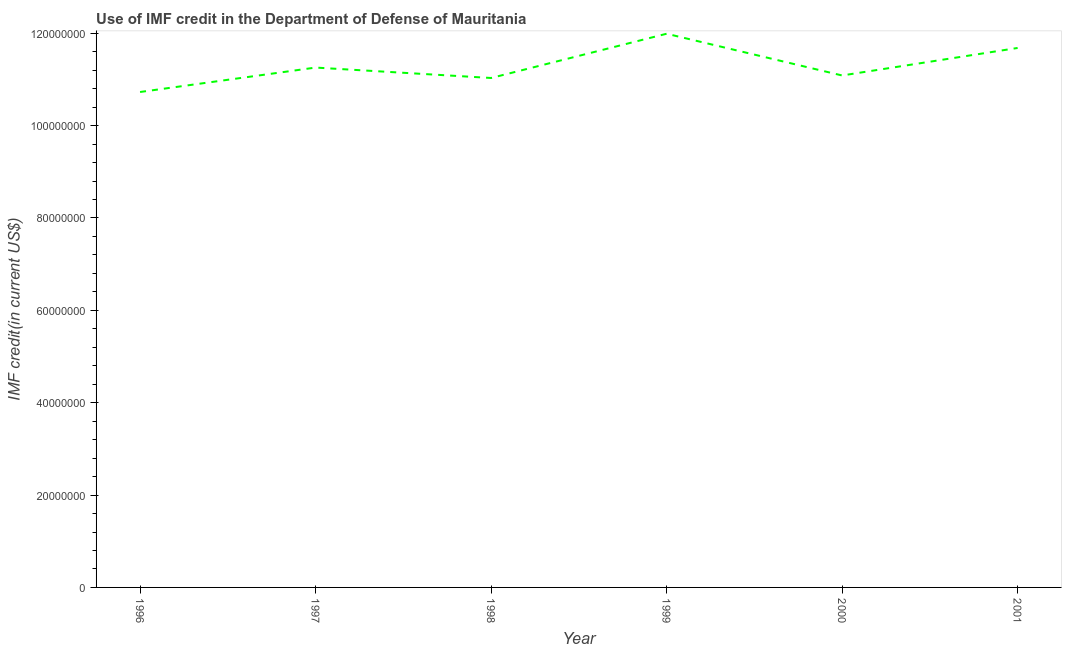What is the use of imf credit in dod in 1996?
Offer a terse response. 1.07e+08. Across all years, what is the maximum use of imf credit in dod?
Provide a short and direct response. 1.20e+08. Across all years, what is the minimum use of imf credit in dod?
Provide a succinct answer. 1.07e+08. In which year was the use of imf credit in dod maximum?
Your answer should be compact. 1999. What is the sum of the use of imf credit in dod?
Give a very brief answer. 6.78e+08. What is the difference between the use of imf credit in dod in 1998 and 1999?
Your response must be concise. -9.58e+06. What is the average use of imf credit in dod per year?
Provide a short and direct response. 1.13e+08. What is the median use of imf credit in dod?
Your answer should be very brief. 1.12e+08. Do a majority of the years between 2001 and 1997 (inclusive) have use of imf credit in dod greater than 32000000 US$?
Your response must be concise. Yes. What is the ratio of the use of imf credit in dod in 1998 to that in 2001?
Offer a very short reply. 0.94. Is the difference between the use of imf credit in dod in 1996 and 2001 greater than the difference between any two years?
Provide a short and direct response. No. What is the difference between the highest and the second highest use of imf credit in dod?
Offer a very short reply. 3.08e+06. What is the difference between the highest and the lowest use of imf credit in dod?
Keep it short and to the point. 1.26e+07. In how many years, is the use of imf credit in dod greater than the average use of imf credit in dod taken over all years?
Offer a terse response. 2. Does the use of imf credit in dod monotonically increase over the years?
Your answer should be very brief. No. How many years are there in the graph?
Offer a very short reply. 6. What is the difference between two consecutive major ticks on the Y-axis?
Your response must be concise. 2.00e+07. Are the values on the major ticks of Y-axis written in scientific E-notation?
Ensure brevity in your answer.  No. Does the graph contain any zero values?
Your response must be concise. No. Does the graph contain grids?
Your answer should be very brief. No. What is the title of the graph?
Provide a succinct answer. Use of IMF credit in the Department of Defense of Mauritania. What is the label or title of the Y-axis?
Your response must be concise. IMF credit(in current US$). What is the IMF credit(in current US$) of 1996?
Provide a succinct answer. 1.07e+08. What is the IMF credit(in current US$) in 1997?
Your answer should be compact. 1.13e+08. What is the IMF credit(in current US$) in 1998?
Your answer should be compact. 1.10e+08. What is the IMF credit(in current US$) in 1999?
Provide a succinct answer. 1.20e+08. What is the IMF credit(in current US$) in 2000?
Provide a short and direct response. 1.11e+08. What is the IMF credit(in current US$) of 2001?
Offer a terse response. 1.17e+08. What is the difference between the IMF credit(in current US$) in 1996 and 1997?
Make the answer very short. -5.29e+06. What is the difference between the IMF credit(in current US$) in 1996 and 1998?
Provide a short and direct response. -3.03e+06. What is the difference between the IMF credit(in current US$) in 1996 and 1999?
Give a very brief answer. -1.26e+07. What is the difference between the IMF credit(in current US$) in 1996 and 2000?
Provide a short and direct response. -3.58e+06. What is the difference between the IMF credit(in current US$) in 1996 and 2001?
Give a very brief answer. -9.54e+06. What is the difference between the IMF credit(in current US$) in 1997 and 1998?
Provide a short and direct response. 2.26e+06. What is the difference between the IMF credit(in current US$) in 1997 and 1999?
Your response must be concise. -7.33e+06. What is the difference between the IMF credit(in current US$) in 1997 and 2000?
Make the answer very short. 1.71e+06. What is the difference between the IMF credit(in current US$) in 1997 and 2001?
Your response must be concise. -4.25e+06. What is the difference between the IMF credit(in current US$) in 1998 and 1999?
Your response must be concise. -9.58e+06. What is the difference between the IMF credit(in current US$) in 1998 and 2000?
Your response must be concise. -5.45e+05. What is the difference between the IMF credit(in current US$) in 1998 and 2001?
Keep it short and to the point. -6.50e+06. What is the difference between the IMF credit(in current US$) in 1999 and 2000?
Make the answer very short. 9.04e+06. What is the difference between the IMF credit(in current US$) in 1999 and 2001?
Give a very brief answer. 3.08e+06. What is the difference between the IMF credit(in current US$) in 2000 and 2001?
Make the answer very short. -5.96e+06. What is the ratio of the IMF credit(in current US$) in 1996 to that in 1997?
Your answer should be very brief. 0.95. What is the ratio of the IMF credit(in current US$) in 1996 to that in 1999?
Your answer should be very brief. 0.9. What is the ratio of the IMF credit(in current US$) in 1996 to that in 2000?
Provide a succinct answer. 0.97. What is the ratio of the IMF credit(in current US$) in 1996 to that in 2001?
Your response must be concise. 0.92. What is the ratio of the IMF credit(in current US$) in 1997 to that in 1998?
Your response must be concise. 1.02. What is the ratio of the IMF credit(in current US$) in 1997 to that in 1999?
Provide a succinct answer. 0.94. What is the ratio of the IMF credit(in current US$) in 1997 to that in 2000?
Provide a short and direct response. 1.01. What is the ratio of the IMF credit(in current US$) in 1997 to that in 2001?
Provide a succinct answer. 0.96. What is the ratio of the IMF credit(in current US$) in 1998 to that in 1999?
Your answer should be compact. 0.92. What is the ratio of the IMF credit(in current US$) in 1998 to that in 2001?
Keep it short and to the point. 0.94. What is the ratio of the IMF credit(in current US$) in 1999 to that in 2000?
Make the answer very short. 1.08. What is the ratio of the IMF credit(in current US$) in 2000 to that in 2001?
Offer a terse response. 0.95. 